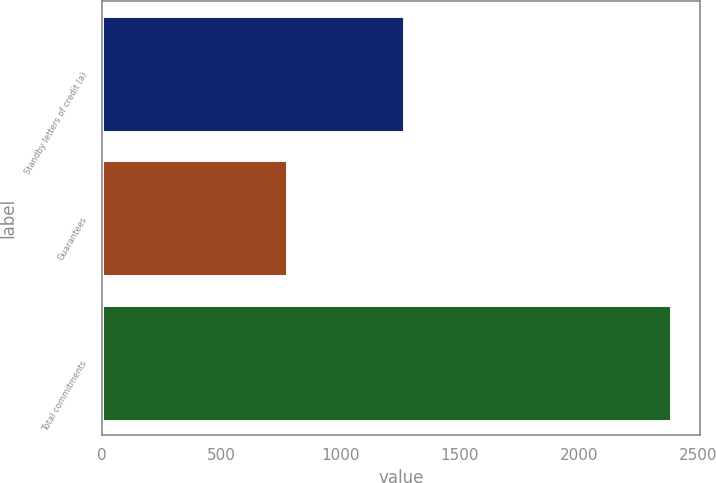Convert chart to OTSL. <chart><loc_0><loc_0><loc_500><loc_500><bar_chart><fcel>Standby letters of credit (a)<fcel>Guarantees<fcel>Total commitments<nl><fcel>1265<fcel>774<fcel>2387<nl></chart> 